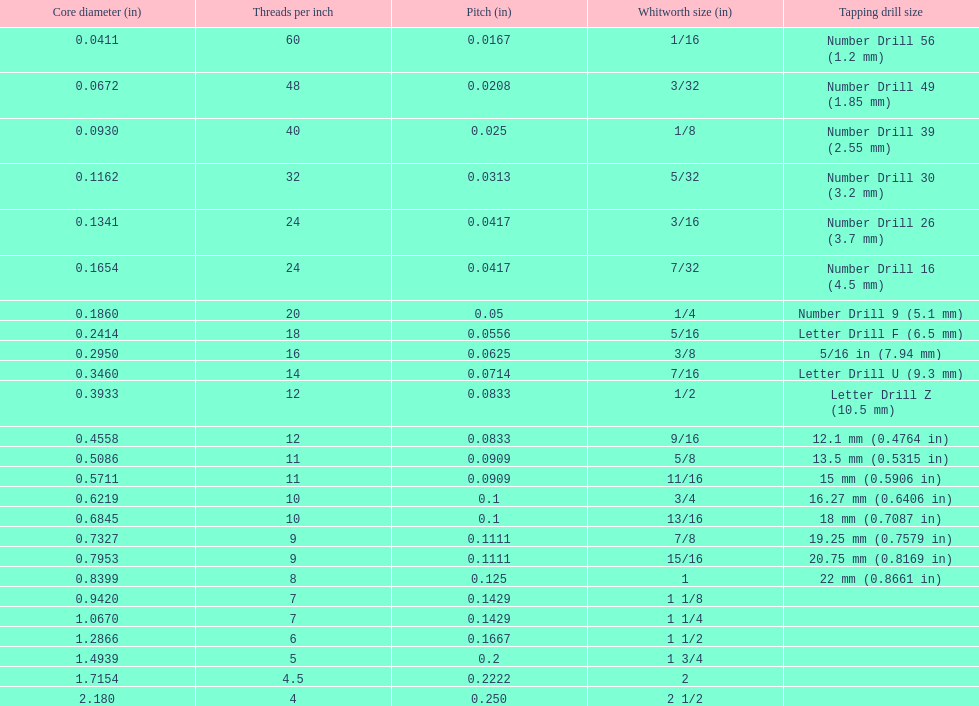What is the least core diameter (in)? 0.0411. 